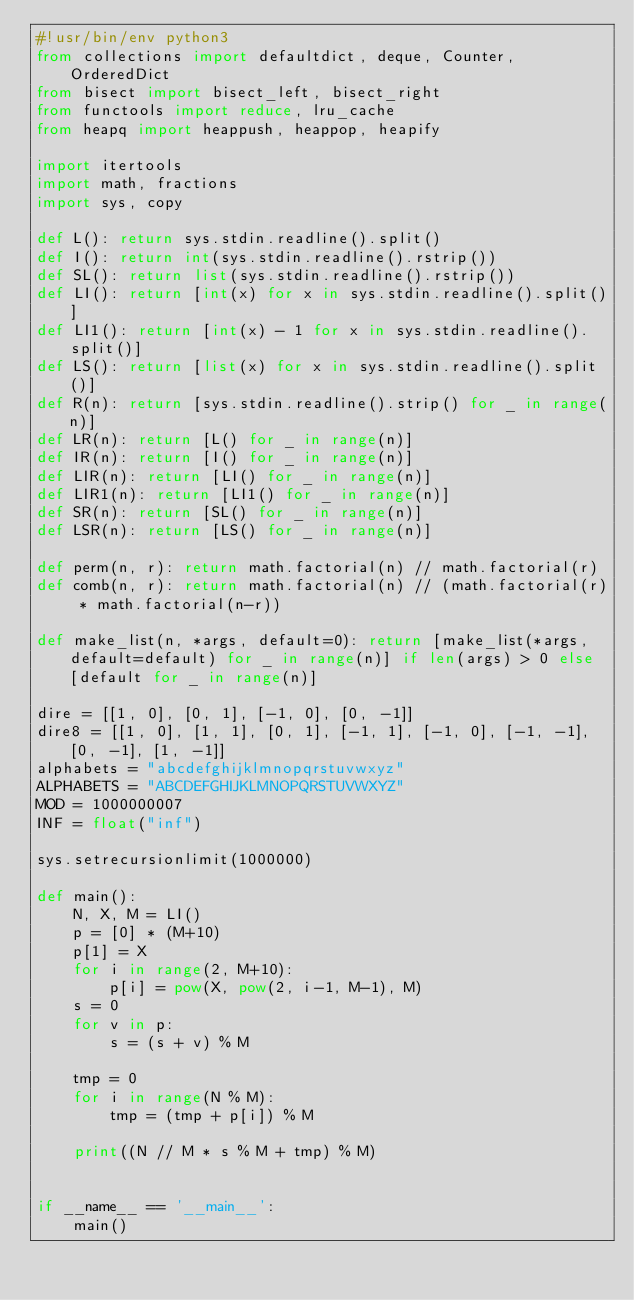Convert code to text. <code><loc_0><loc_0><loc_500><loc_500><_Python_>#!usr/bin/env python3
from collections import defaultdict, deque, Counter, OrderedDict
from bisect import bisect_left, bisect_right
from functools import reduce, lru_cache
from heapq import heappush, heappop, heapify

import itertools
import math, fractions
import sys, copy

def L(): return sys.stdin.readline().split()
def I(): return int(sys.stdin.readline().rstrip())
def SL(): return list(sys.stdin.readline().rstrip())
def LI(): return [int(x) for x in sys.stdin.readline().split()]
def LI1(): return [int(x) - 1 for x in sys.stdin.readline().split()]
def LS(): return [list(x) for x in sys.stdin.readline().split()]
def R(n): return [sys.stdin.readline().strip() for _ in range(n)]
def LR(n): return [L() for _ in range(n)]
def IR(n): return [I() for _ in range(n)]
def LIR(n): return [LI() for _ in range(n)]
def LIR1(n): return [LI1() for _ in range(n)]
def SR(n): return [SL() for _ in range(n)]
def LSR(n): return [LS() for _ in range(n)]

def perm(n, r): return math.factorial(n) // math.factorial(r)
def comb(n, r): return math.factorial(n) // (math.factorial(r) * math.factorial(n-r))

def make_list(n, *args, default=0): return [make_list(*args, default=default) for _ in range(n)] if len(args) > 0 else [default for _ in range(n)]

dire = [[1, 0], [0, 1], [-1, 0], [0, -1]]
dire8 = [[1, 0], [1, 1], [0, 1], [-1, 1], [-1, 0], [-1, -1], [0, -1], [1, -1]]
alphabets = "abcdefghijklmnopqrstuvwxyz"
ALPHABETS = "ABCDEFGHIJKLMNOPQRSTUVWXYZ"
MOD = 1000000007
INF = float("inf")

sys.setrecursionlimit(1000000)

def main():
    N, X, M = LI()
    p = [0] * (M+10)
    p[1] = X
    for i in range(2, M+10):
        p[i] = pow(X, pow(2, i-1, M-1), M)
    s = 0
    for v in p:
        s = (s + v) % M

    tmp = 0
    for i in range(N % M):
        tmp = (tmp + p[i]) % M

    print((N // M * s % M + tmp) % M)


if __name__ == '__main__':
    main()</code> 